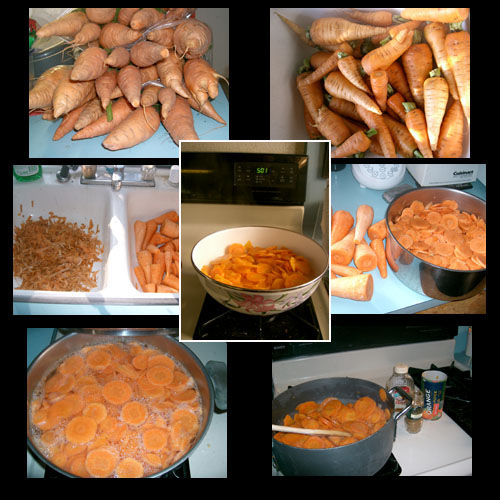<image>Are sweet potatoes classified as tubers? It is not sure whether sweet potatoes are classified as tubers. Are sweet potatoes classified as tubers? Yes, sweet potatoes are classified as tubers. 